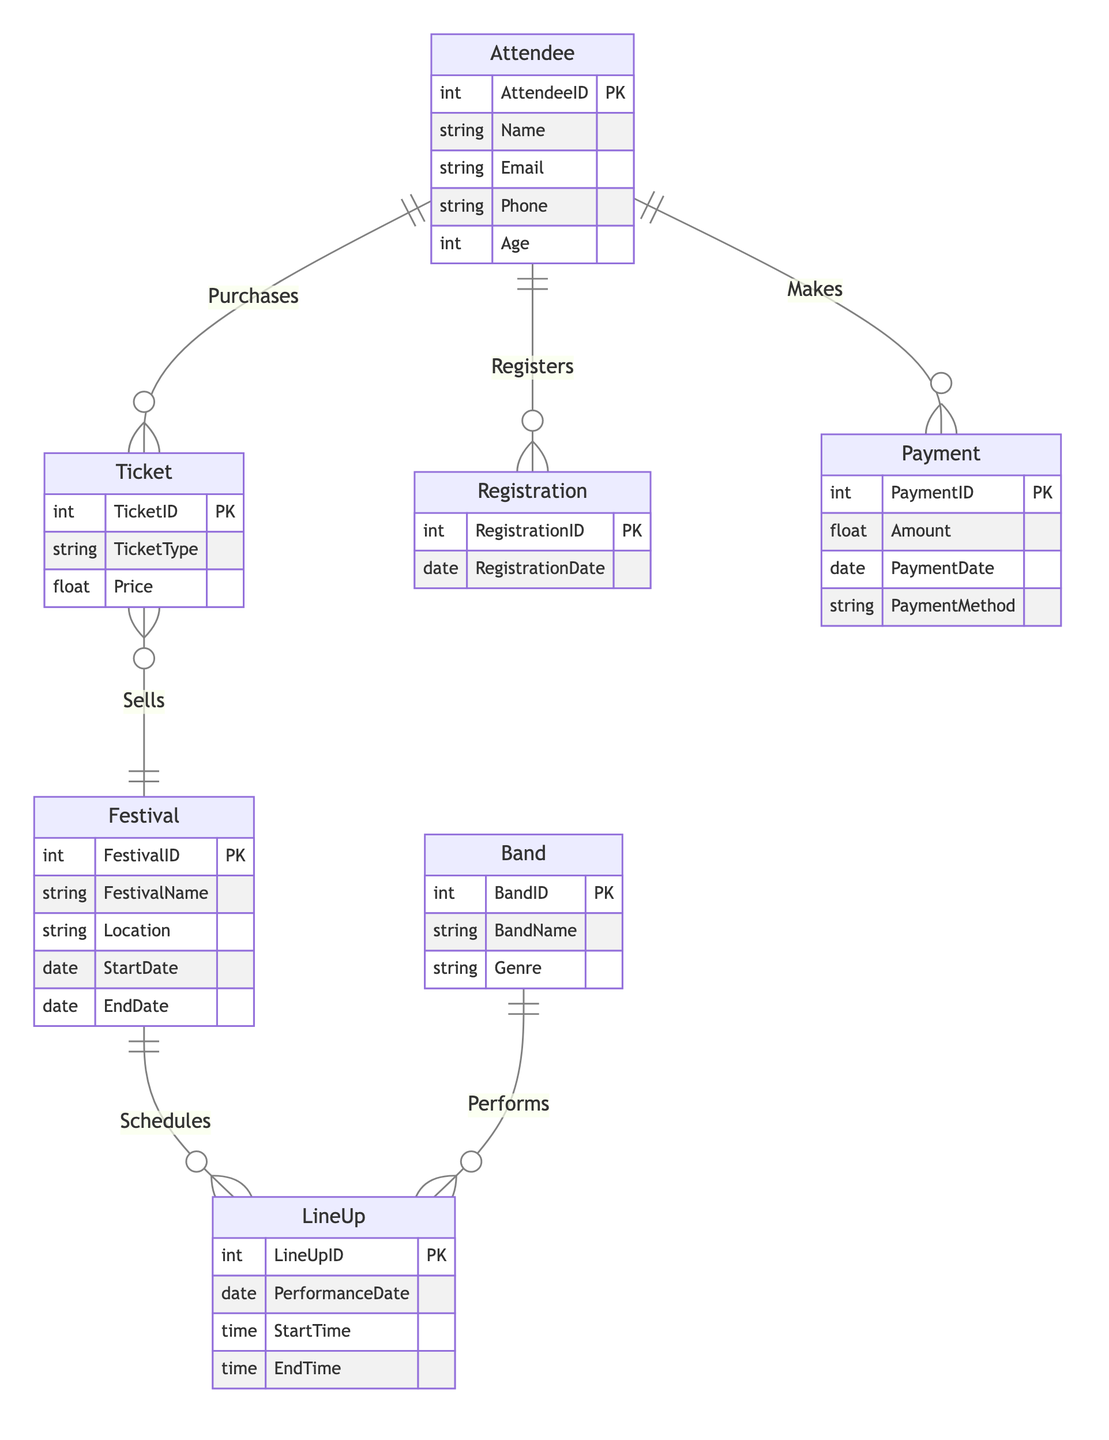What is the primary key of the Attendee entity? The primary key of the Attendee entity is AttendeeID, which uniquely identifies each attendee in the database.
Answer: AttendeeID How many entities are present in the diagram? The diagram contains a total of 7 entities: Attendee, Ticket, Registration, Payment, Band, Festival, and LineUp.
Answer: 7 What relationship exists between Band and LineUp? The relationship between Band and LineUp is labeled "Performs," indicating that bands perform during specific lineup events.
Answer: Performs Which entity has an attribute called Price? The entity that has an attribute called Price is Ticket, which indicates the cost of each ticket type available for purchase.
Answer: Ticket How many relationships are defined between entities in the diagram? The diagram shows 6 distinct relationships connecting different entities, illustrating how they interact with one another.
Answer: 6 What is the attribute shared between the Attendee and Payment entities? The shared attribute between the Attendee and Payment entities is PaymentID, which is represented in the Payment entity where it relates to the attendee making the payment.
Answer: PaymentID Which entity is responsible for scheduling the LineUp? The entity responsible for scheduling the LineUp is Festival, indicating that festivals manage their performance schedules.
Answer: Festival What can you say about the relationship "Sells"? The relationship "Sells" links Ticket and Festival, indicating that tickets are sold for specific festivals.
Answer: Sells What is the importance of the Registration entity? The Registration entity records the RegistrationID and RegistrationDate, tracking when attendees register for the festival, which is essential for managing attendee information.
Answer: RegistrationID and RegistrationDate 